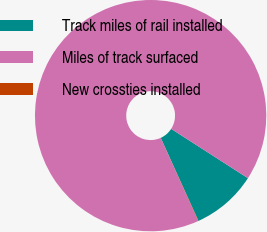<chart> <loc_0><loc_0><loc_500><loc_500><pie_chart><fcel>Track miles of rail installed<fcel>Miles of track surfaced<fcel>New crossties installed<nl><fcel>9.12%<fcel>90.83%<fcel>0.04%<nl></chart> 